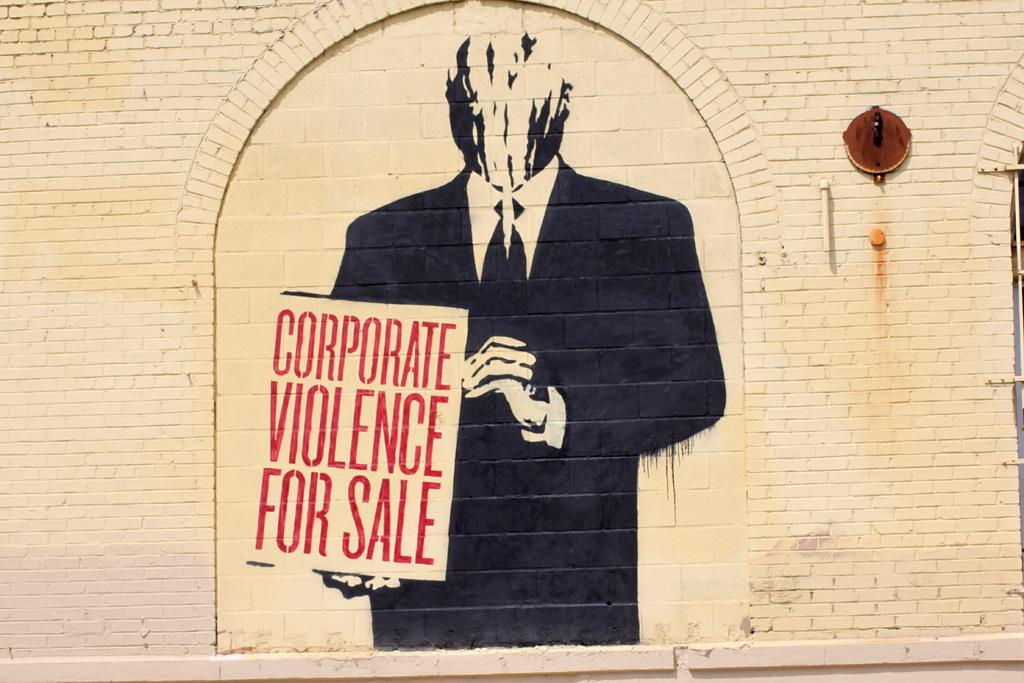What is present on the wall in the image? There is a painting on the wall. What is the subject of the painting? The painting depicts a person holding a board. What type of fire can be seen in the painting? There is no fire present in the painting; it depicts a person holding a board. What time of day is depicted in the painting? The painting does not depict a specific time of day; it only shows a person holding a board. 